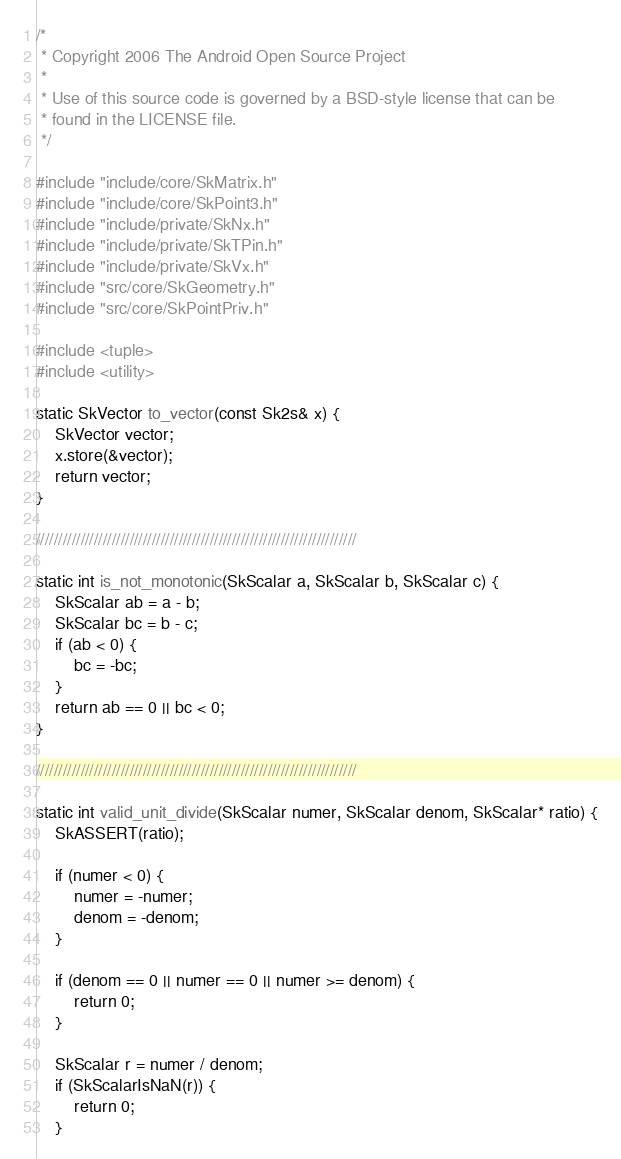<code> <loc_0><loc_0><loc_500><loc_500><_C++_>/*
 * Copyright 2006 The Android Open Source Project
 *
 * Use of this source code is governed by a BSD-style license that can be
 * found in the LICENSE file.
 */

#include "include/core/SkMatrix.h"
#include "include/core/SkPoint3.h"
#include "include/private/SkNx.h"
#include "include/private/SkTPin.h"
#include "include/private/SkVx.h"
#include "src/core/SkGeometry.h"
#include "src/core/SkPointPriv.h"

#include <tuple>
#include <utility>

static SkVector to_vector(const Sk2s& x) {
    SkVector vector;
    x.store(&vector);
    return vector;
}

////////////////////////////////////////////////////////////////////////

static int is_not_monotonic(SkScalar a, SkScalar b, SkScalar c) {
    SkScalar ab = a - b;
    SkScalar bc = b - c;
    if (ab < 0) {
        bc = -bc;
    }
    return ab == 0 || bc < 0;
}

////////////////////////////////////////////////////////////////////////

static int valid_unit_divide(SkScalar numer, SkScalar denom, SkScalar* ratio) {
    SkASSERT(ratio);

    if (numer < 0) {
        numer = -numer;
        denom = -denom;
    }

    if (denom == 0 || numer == 0 || numer >= denom) {
        return 0;
    }

    SkScalar r = numer / denom;
    if (SkScalarIsNaN(r)) {
        return 0;
    }</code> 